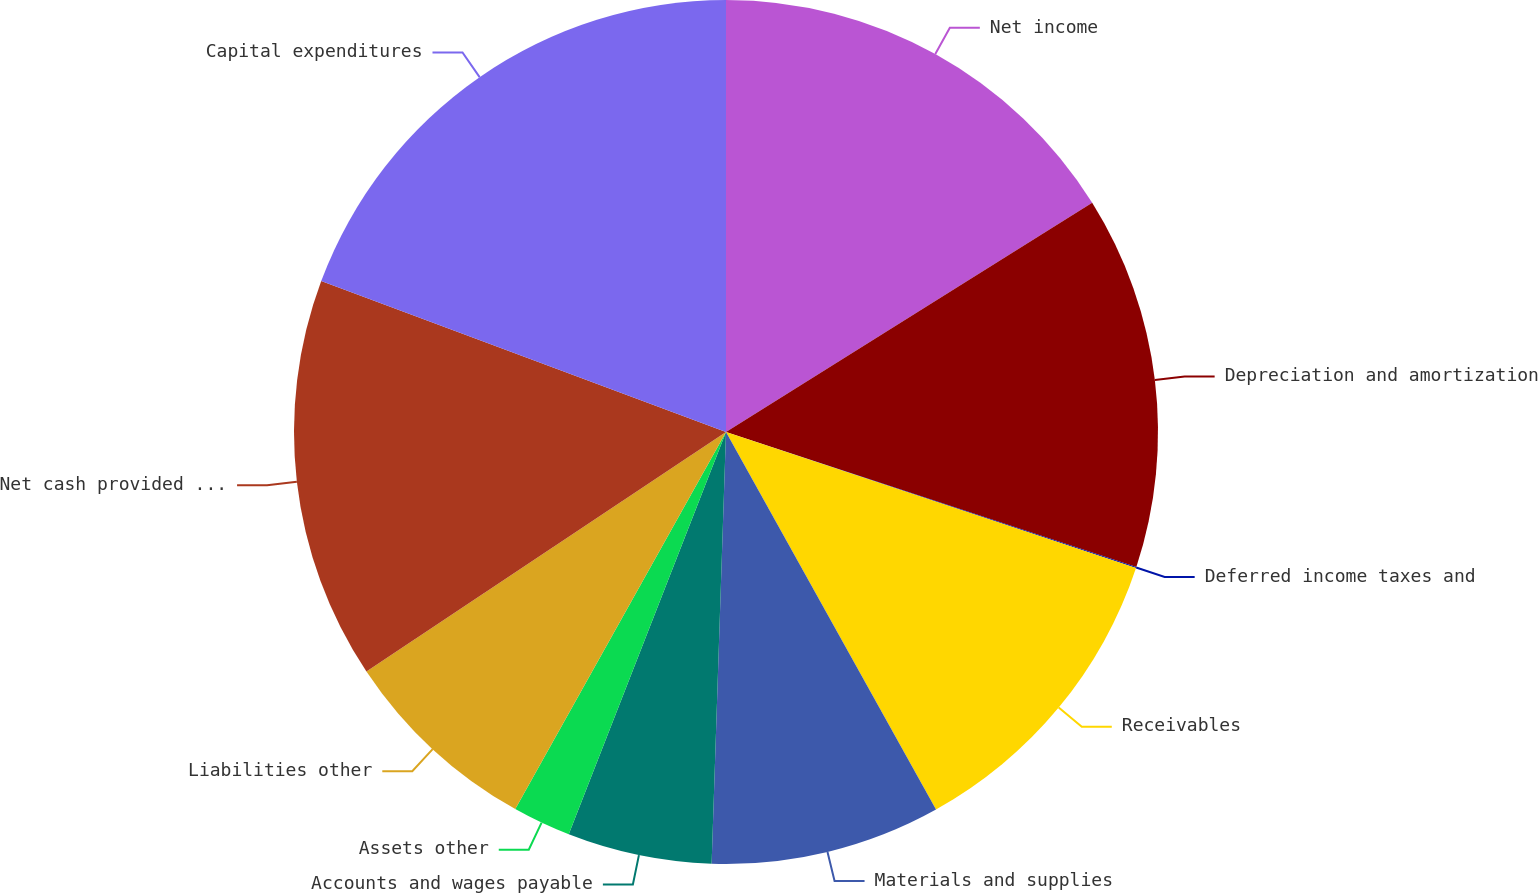Convert chart to OTSL. <chart><loc_0><loc_0><loc_500><loc_500><pie_chart><fcel>Net income<fcel>Depreciation and amortization<fcel>Deferred income taxes and<fcel>Receivables<fcel>Materials and supplies<fcel>Accounts and wages payable<fcel>Assets other<fcel>Liabilities other<fcel>Net cash provided by operating<fcel>Capital expenditures<nl><fcel>16.1%<fcel>13.96%<fcel>0.04%<fcel>11.82%<fcel>8.61%<fcel>5.4%<fcel>2.18%<fcel>7.54%<fcel>15.03%<fcel>19.32%<nl></chart> 